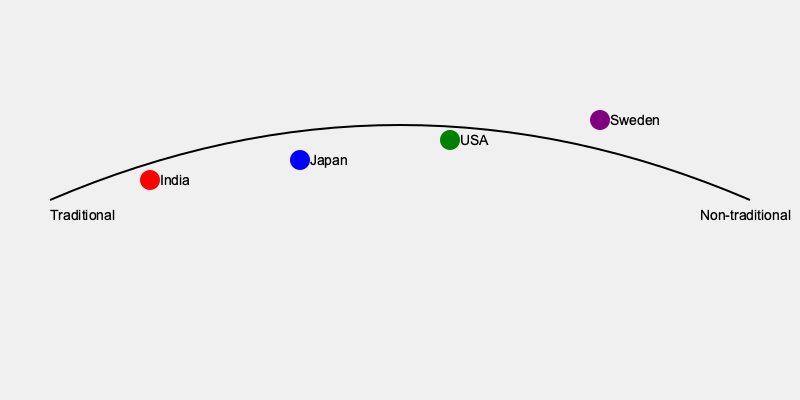Based on the graph showing the spectrum of wedding practices from traditional to non-traditional, which country appears to have the most progressive approach to weddings, potentially challenging outdated societal norms? To answer this question, we need to analyze the graph and understand its implications:

1. The graph represents a spectrum from traditional (left) to non-traditional (right) wedding practices.
2. Four countries are plotted on this spectrum: India, Japan, USA, and Sweden.
3. The vertical position of each country's marker indicates its relative position on the traditional to non-traditional spectrum.
4. India is positioned furthest to the left, suggesting the most traditional practices.
5. Japan is slightly to the right of India, indicating somewhat less traditional practices.
6. The USA is positioned further right, suggesting more non-traditional practices than India and Japan.
7. Sweden is positioned furthest to the right, indicating the most non-traditional or progressive wedding practices among the countries shown.

Given the persona of a sociologist who believes wedding rituals are outdated and reinforce negative societal norms, the country furthest to the right (non-traditional end) would be considered as having the most progressive approach to weddings, potentially challenging outdated societal norms.
Answer: Sweden 